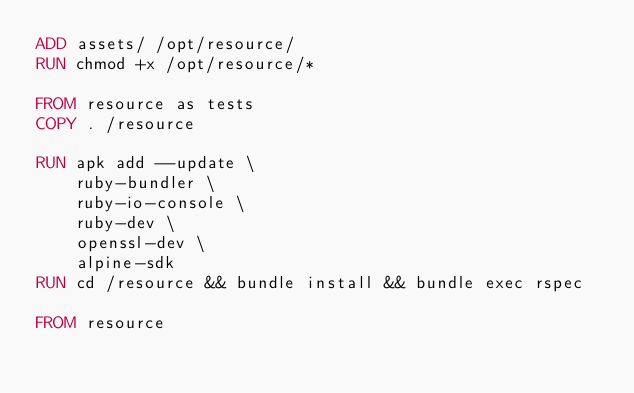Convert code to text. <code><loc_0><loc_0><loc_500><loc_500><_Dockerfile_>ADD assets/ /opt/resource/
RUN chmod +x /opt/resource/*

FROM resource as tests
COPY . /resource

RUN apk add --update \
    ruby-bundler \
    ruby-io-console \
    ruby-dev \
    openssl-dev \
    alpine-sdk
RUN cd /resource && bundle install && bundle exec rspec

FROM resource
</code> 